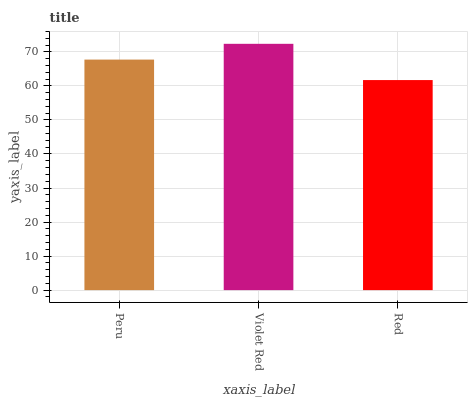Is Red the minimum?
Answer yes or no. Yes. Is Violet Red the maximum?
Answer yes or no. Yes. Is Violet Red the minimum?
Answer yes or no. No. Is Red the maximum?
Answer yes or no. No. Is Violet Red greater than Red?
Answer yes or no. Yes. Is Red less than Violet Red?
Answer yes or no. Yes. Is Red greater than Violet Red?
Answer yes or no. No. Is Violet Red less than Red?
Answer yes or no. No. Is Peru the high median?
Answer yes or no. Yes. Is Peru the low median?
Answer yes or no. Yes. Is Red the high median?
Answer yes or no. No. Is Violet Red the low median?
Answer yes or no. No. 